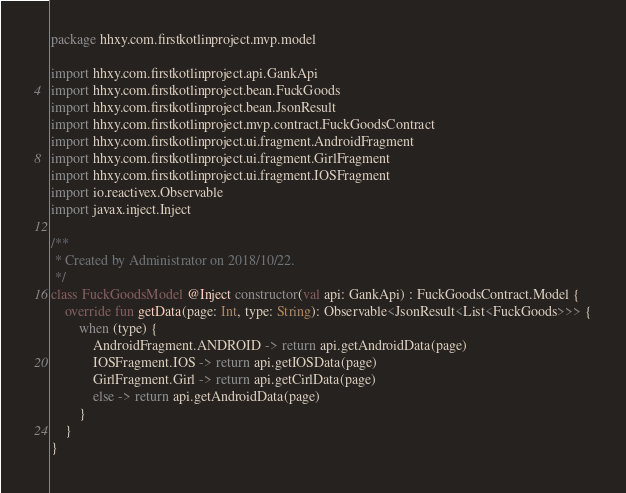<code> <loc_0><loc_0><loc_500><loc_500><_Kotlin_>package hhxy.com.firstkotlinproject.mvp.model

import hhxy.com.firstkotlinproject.api.GankApi
import hhxy.com.firstkotlinproject.bean.FuckGoods
import hhxy.com.firstkotlinproject.bean.JsonResult
import hhxy.com.firstkotlinproject.mvp.contract.FuckGoodsContract
import hhxy.com.firstkotlinproject.ui.fragment.AndroidFragment
import hhxy.com.firstkotlinproject.ui.fragment.GirlFragment
import hhxy.com.firstkotlinproject.ui.fragment.IOSFragment
import io.reactivex.Observable
import javax.inject.Inject

/**
 * Created by Administrator on 2018/10/22.
 */
class FuckGoodsModel @Inject constructor(val api: GankApi) : FuckGoodsContract.Model {
    override fun getData(page: Int, type: String): Observable<JsonResult<List<FuckGoods>>> {
        when (type) {
            AndroidFragment.ANDROID -> return api.getAndroidData(page)
            IOSFragment.IOS -> return api.getIOSData(page)
            GirlFragment.Girl -> return api.getCirlData(page)
            else -> return api.getAndroidData(page)
        }
    }
}</code> 